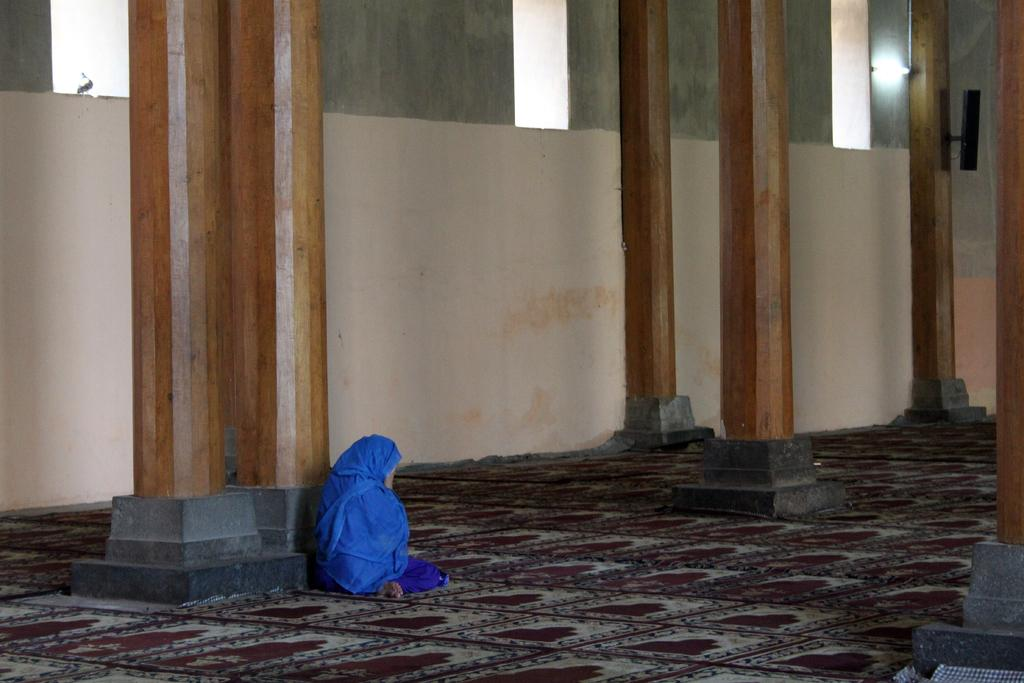What is the person in the image doing? The person is on the ground in the image. What can be seen beneath the person? The ground is visible in the image. What architectural features are present in the image? There are pillars and a wall with lights in the image. What is attached to the wall in the image? There are objects attached to the wall in the image. What type of jar can be seen rolling on the ground in the image? There is no jar present in the image, and therefore no such activity can be observed. 